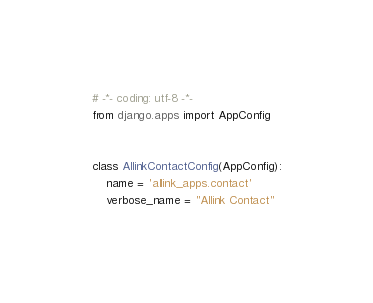<code> <loc_0><loc_0><loc_500><loc_500><_Python_># -*- coding: utf-8 -*-
from django.apps import AppConfig


class AllinkContactConfig(AppConfig):
    name = 'allink_apps.contact'
    verbose_name = "Allink Contact"
</code> 